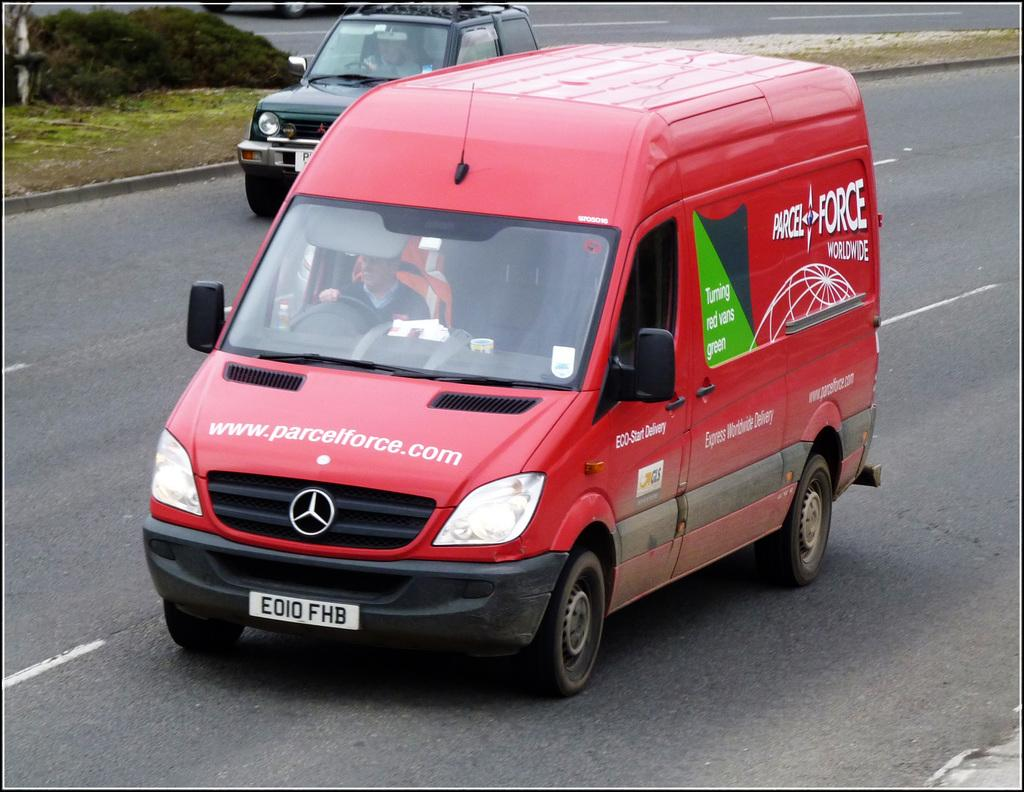<image>
Give a short and clear explanation of the subsequent image. A re delivery fan on the road from Parcel Force 